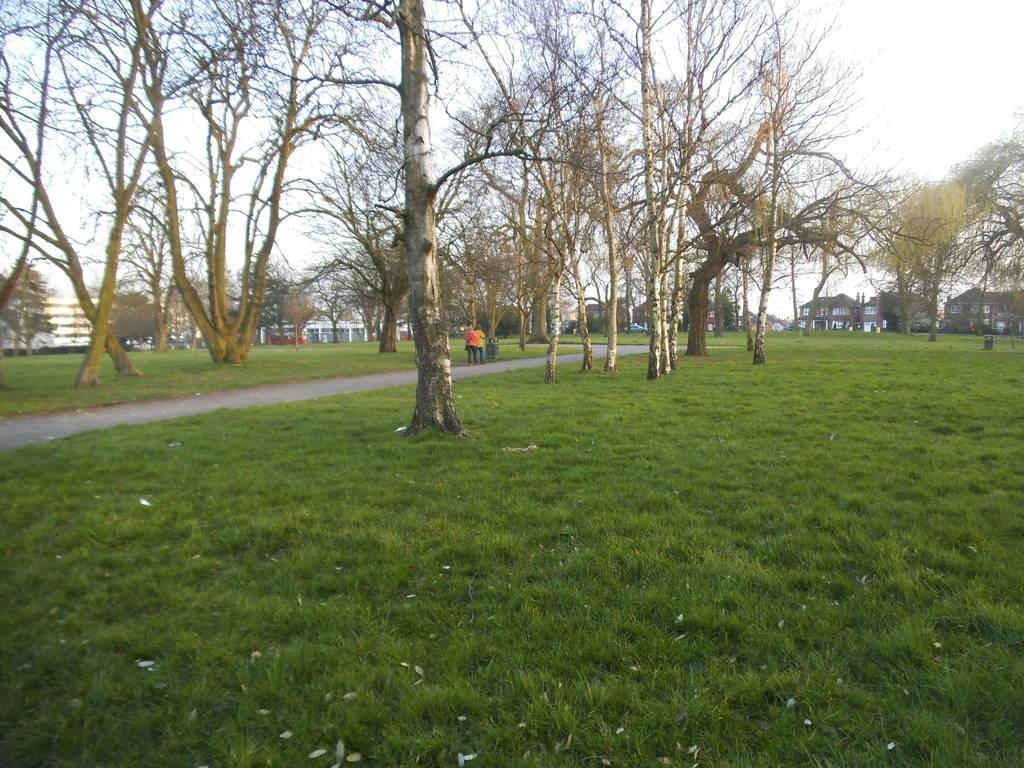What type of vegetation is present in the image? There are trees in the image. What type of structures can be seen in the image? There are buildings in the image. Are there any people visible in the image? Yes, some people are standing in the image. What is the ground covered with in the image? There is grass on the ground in the image. How would you describe the sky in the image? The sky is cloudy in the image. Can you see your mom in the image? There is no information about your mom in the image, so we cannot determine if she is present or not. Are there any rabbits visible in the image? There is no mention of rabbits in the image, so we cannot confirm their presence. 